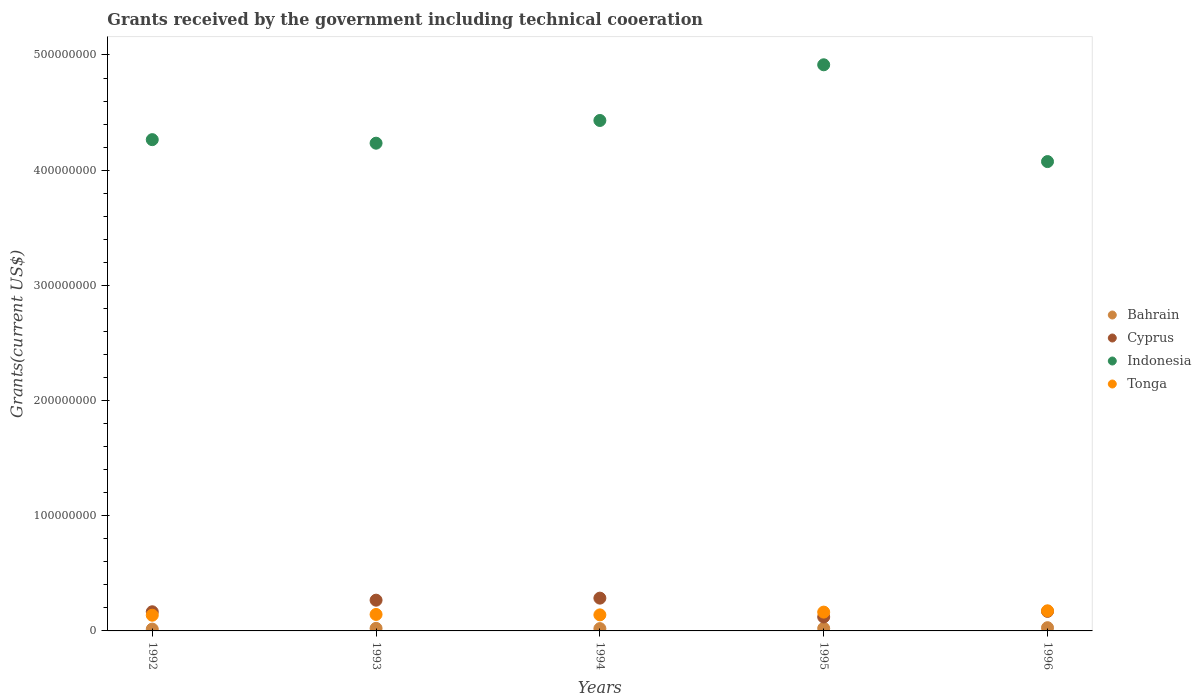How many different coloured dotlines are there?
Offer a terse response. 4. Is the number of dotlines equal to the number of legend labels?
Offer a very short reply. Yes. What is the total grants received by the government in Tonga in 1996?
Offer a terse response. 1.75e+07. Across all years, what is the maximum total grants received by the government in Bahrain?
Provide a succinct answer. 2.80e+06. Across all years, what is the minimum total grants received by the government in Bahrain?
Give a very brief answer. 1.59e+06. What is the total total grants received by the government in Bahrain in the graph?
Your response must be concise. 1.09e+07. What is the difference between the total grants received by the government in Tonga in 1994 and that in 1996?
Offer a very short reply. -3.53e+06. What is the difference between the total grants received by the government in Tonga in 1995 and the total grants received by the government in Indonesia in 1996?
Make the answer very short. -3.91e+08. What is the average total grants received by the government in Indonesia per year?
Offer a terse response. 4.38e+08. In the year 1994, what is the difference between the total grants received by the government in Bahrain and total grants received by the government in Cyprus?
Your answer should be very brief. -2.64e+07. In how many years, is the total grants received by the government in Tonga greater than 140000000 US$?
Your answer should be very brief. 0. What is the ratio of the total grants received by the government in Bahrain in 1993 to that in 1994?
Provide a succinct answer. 1.11. Is the difference between the total grants received by the government in Bahrain in 1993 and 1995 greater than the difference between the total grants received by the government in Cyprus in 1993 and 1995?
Your answer should be compact. No. What is the difference between the highest and the second highest total grants received by the government in Tonga?
Provide a succinct answer. 1.13e+06. What is the difference between the highest and the lowest total grants received by the government in Cyprus?
Your response must be concise. 1.64e+07. Is it the case that in every year, the sum of the total grants received by the government in Cyprus and total grants received by the government in Tonga  is greater than the total grants received by the government in Bahrain?
Give a very brief answer. Yes. Is the total grants received by the government in Indonesia strictly greater than the total grants received by the government in Bahrain over the years?
Offer a terse response. Yes. How many years are there in the graph?
Provide a short and direct response. 5. What is the difference between two consecutive major ticks on the Y-axis?
Ensure brevity in your answer.  1.00e+08. Does the graph contain grids?
Give a very brief answer. No. What is the title of the graph?
Ensure brevity in your answer.  Grants received by the government including technical cooeration. Does "Netherlands" appear as one of the legend labels in the graph?
Offer a terse response. No. What is the label or title of the X-axis?
Offer a terse response. Years. What is the label or title of the Y-axis?
Offer a very short reply. Grants(current US$). What is the Grants(current US$) of Bahrain in 1992?
Make the answer very short. 1.59e+06. What is the Grants(current US$) in Cyprus in 1992?
Your response must be concise. 1.66e+07. What is the Grants(current US$) of Indonesia in 1992?
Give a very brief answer. 4.26e+08. What is the Grants(current US$) in Tonga in 1992?
Ensure brevity in your answer.  1.36e+07. What is the Grants(current US$) in Bahrain in 1993?
Make the answer very short. 2.24e+06. What is the Grants(current US$) in Cyprus in 1993?
Your response must be concise. 2.67e+07. What is the Grants(current US$) of Indonesia in 1993?
Provide a succinct answer. 4.23e+08. What is the Grants(current US$) of Tonga in 1993?
Your response must be concise. 1.43e+07. What is the Grants(current US$) in Bahrain in 1994?
Keep it short and to the point. 2.02e+06. What is the Grants(current US$) of Cyprus in 1994?
Provide a succinct answer. 2.85e+07. What is the Grants(current US$) of Indonesia in 1994?
Provide a short and direct response. 4.43e+08. What is the Grants(current US$) of Tonga in 1994?
Your response must be concise. 1.39e+07. What is the Grants(current US$) of Bahrain in 1995?
Your answer should be compact. 2.24e+06. What is the Grants(current US$) of Cyprus in 1995?
Give a very brief answer. 1.21e+07. What is the Grants(current US$) in Indonesia in 1995?
Provide a succinct answer. 4.91e+08. What is the Grants(current US$) in Tonga in 1995?
Provide a succinct answer. 1.63e+07. What is the Grants(current US$) in Bahrain in 1996?
Offer a terse response. 2.80e+06. What is the Grants(current US$) of Cyprus in 1996?
Give a very brief answer. 1.70e+07. What is the Grants(current US$) in Indonesia in 1996?
Your answer should be compact. 4.07e+08. What is the Grants(current US$) in Tonga in 1996?
Keep it short and to the point. 1.75e+07. Across all years, what is the maximum Grants(current US$) in Bahrain?
Ensure brevity in your answer.  2.80e+06. Across all years, what is the maximum Grants(current US$) of Cyprus?
Your response must be concise. 2.85e+07. Across all years, what is the maximum Grants(current US$) in Indonesia?
Ensure brevity in your answer.  4.91e+08. Across all years, what is the maximum Grants(current US$) of Tonga?
Keep it short and to the point. 1.75e+07. Across all years, what is the minimum Grants(current US$) of Bahrain?
Make the answer very short. 1.59e+06. Across all years, what is the minimum Grants(current US$) in Cyprus?
Your answer should be very brief. 1.21e+07. Across all years, what is the minimum Grants(current US$) of Indonesia?
Your answer should be compact. 4.07e+08. Across all years, what is the minimum Grants(current US$) of Tonga?
Your answer should be very brief. 1.36e+07. What is the total Grants(current US$) of Bahrain in the graph?
Give a very brief answer. 1.09e+07. What is the total Grants(current US$) in Cyprus in the graph?
Make the answer very short. 1.01e+08. What is the total Grants(current US$) of Indonesia in the graph?
Provide a short and direct response. 2.19e+09. What is the total Grants(current US$) of Tonga in the graph?
Provide a succinct answer. 7.56e+07. What is the difference between the Grants(current US$) of Bahrain in 1992 and that in 1993?
Offer a very short reply. -6.50e+05. What is the difference between the Grants(current US$) of Cyprus in 1992 and that in 1993?
Provide a short and direct response. -1.01e+07. What is the difference between the Grants(current US$) in Indonesia in 1992 and that in 1993?
Keep it short and to the point. 3.07e+06. What is the difference between the Grants(current US$) of Tonga in 1992 and that in 1993?
Provide a succinct answer. -6.70e+05. What is the difference between the Grants(current US$) in Bahrain in 1992 and that in 1994?
Offer a very short reply. -4.30e+05. What is the difference between the Grants(current US$) of Cyprus in 1992 and that in 1994?
Make the answer very short. -1.18e+07. What is the difference between the Grants(current US$) in Indonesia in 1992 and that in 1994?
Offer a very short reply. -1.66e+07. What is the difference between the Grants(current US$) in Bahrain in 1992 and that in 1995?
Your response must be concise. -6.50e+05. What is the difference between the Grants(current US$) in Cyprus in 1992 and that in 1995?
Provide a short and direct response. 4.51e+06. What is the difference between the Grants(current US$) of Indonesia in 1992 and that in 1995?
Your response must be concise. -6.50e+07. What is the difference between the Grants(current US$) of Tonga in 1992 and that in 1995?
Your answer should be very brief. -2.70e+06. What is the difference between the Grants(current US$) in Bahrain in 1992 and that in 1996?
Offer a terse response. -1.21e+06. What is the difference between the Grants(current US$) of Cyprus in 1992 and that in 1996?
Offer a very short reply. -3.50e+05. What is the difference between the Grants(current US$) in Indonesia in 1992 and that in 1996?
Make the answer very short. 1.90e+07. What is the difference between the Grants(current US$) of Tonga in 1992 and that in 1996?
Your answer should be compact. -3.83e+06. What is the difference between the Grants(current US$) of Bahrain in 1993 and that in 1994?
Offer a very short reply. 2.20e+05. What is the difference between the Grants(current US$) of Cyprus in 1993 and that in 1994?
Provide a short and direct response. -1.77e+06. What is the difference between the Grants(current US$) of Indonesia in 1993 and that in 1994?
Keep it short and to the point. -1.97e+07. What is the difference between the Grants(current US$) in Bahrain in 1993 and that in 1995?
Keep it short and to the point. 0. What is the difference between the Grants(current US$) of Cyprus in 1993 and that in 1995?
Give a very brief answer. 1.46e+07. What is the difference between the Grants(current US$) in Indonesia in 1993 and that in 1995?
Give a very brief answer. -6.81e+07. What is the difference between the Grants(current US$) of Tonga in 1993 and that in 1995?
Provide a short and direct response. -2.03e+06. What is the difference between the Grants(current US$) of Bahrain in 1993 and that in 1996?
Your response must be concise. -5.60e+05. What is the difference between the Grants(current US$) in Cyprus in 1993 and that in 1996?
Give a very brief answer. 9.72e+06. What is the difference between the Grants(current US$) of Indonesia in 1993 and that in 1996?
Provide a succinct answer. 1.60e+07. What is the difference between the Grants(current US$) in Tonga in 1993 and that in 1996?
Make the answer very short. -3.16e+06. What is the difference between the Grants(current US$) of Cyprus in 1994 and that in 1995?
Make the answer very short. 1.64e+07. What is the difference between the Grants(current US$) in Indonesia in 1994 and that in 1995?
Give a very brief answer. -4.83e+07. What is the difference between the Grants(current US$) in Tonga in 1994 and that in 1995?
Make the answer very short. -2.40e+06. What is the difference between the Grants(current US$) in Bahrain in 1994 and that in 1996?
Make the answer very short. -7.80e+05. What is the difference between the Grants(current US$) in Cyprus in 1994 and that in 1996?
Keep it short and to the point. 1.15e+07. What is the difference between the Grants(current US$) in Indonesia in 1994 and that in 1996?
Keep it short and to the point. 3.57e+07. What is the difference between the Grants(current US$) in Tonga in 1994 and that in 1996?
Offer a very short reply. -3.53e+06. What is the difference between the Grants(current US$) of Bahrain in 1995 and that in 1996?
Your answer should be very brief. -5.60e+05. What is the difference between the Grants(current US$) of Cyprus in 1995 and that in 1996?
Provide a succinct answer. -4.86e+06. What is the difference between the Grants(current US$) in Indonesia in 1995 and that in 1996?
Your answer should be very brief. 8.40e+07. What is the difference between the Grants(current US$) of Tonga in 1995 and that in 1996?
Give a very brief answer. -1.13e+06. What is the difference between the Grants(current US$) in Bahrain in 1992 and the Grants(current US$) in Cyprus in 1993?
Make the answer very short. -2.51e+07. What is the difference between the Grants(current US$) in Bahrain in 1992 and the Grants(current US$) in Indonesia in 1993?
Provide a short and direct response. -4.22e+08. What is the difference between the Grants(current US$) of Bahrain in 1992 and the Grants(current US$) of Tonga in 1993?
Provide a short and direct response. -1.27e+07. What is the difference between the Grants(current US$) in Cyprus in 1992 and the Grants(current US$) in Indonesia in 1993?
Give a very brief answer. -4.07e+08. What is the difference between the Grants(current US$) of Cyprus in 1992 and the Grants(current US$) of Tonga in 1993?
Offer a very short reply. 2.32e+06. What is the difference between the Grants(current US$) of Indonesia in 1992 and the Grants(current US$) of Tonga in 1993?
Your answer should be very brief. 4.12e+08. What is the difference between the Grants(current US$) in Bahrain in 1992 and the Grants(current US$) in Cyprus in 1994?
Your response must be concise. -2.69e+07. What is the difference between the Grants(current US$) of Bahrain in 1992 and the Grants(current US$) of Indonesia in 1994?
Provide a short and direct response. -4.42e+08. What is the difference between the Grants(current US$) in Bahrain in 1992 and the Grants(current US$) in Tonga in 1994?
Ensure brevity in your answer.  -1.23e+07. What is the difference between the Grants(current US$) of Cyprus in 1992 and the Grants(current US$) of Indonesia in 1994?
Your answer should be very brief. -4.27e+08. What is the difference between the Grants(current US$) in Cyprus in 1992 and the Grants(current US$) in Tonga in 1994?
Your response must be concise. 2.69e+06. What is the difference between the Grants(current US$) in Indonesia in 1992 and the Grants(current US$) in Tonga in 1994?
Give a very brief answer. 4.13e+08. What is the difference between the Grants(current US$) in Bahrain in 1992 and the Grants(current US$) in Cyprus in 1995?
Offer a very short reply. -1.05e+07. What is the difference between the Grants(current US$) in Bahrain in 1992 and the Grants(current US$) in Indonesia in 1995?
Your answer should be very brief. -4.90e+08. What is the difference between the Grants(current US$) in Bahrain in 1992 and the Grants(current US$) in Tonga in 1995?
Give a very brief answer. -1.47e+07. What is the difference between the Grants(current US$) of Cyprus in 1992 and the Grants(current US$) of Indonesia in 1995?
Keep it short and to the point. -4.75e+08. What is the difference between the Grants(current US$) of Cyprus in 1992 and the Grants(current US$) of Tonga in 1995?
Keep it short and to the point. 2.90e+05. What is the difference between the Grants(current US$) of Indonesia in 1992 and the Grants(current US$) of Tonga in 1995?
Make the answer very short. 4.10e+08. What is the difference between the Grants(current US$) in Bahrain in 1992 and the Grants(current US$) in Cyprus in 1996?
Your response must be concise. -1.54e+07. What is the difference between the Grants(current US$) in Bahrain in 1992 and the Grants(current US$) in Indonesia in 1996?
Your answer should be compact. -4.06e+08. What is the difference between the Grants(current US$) in Bahrain in 1992 and the Grants(current US$) in Tonga in 1996?
Offer a terse response. -1.59e+07. What is the difference between the Grants(current US$) of Cyprus in 1992 and the Grants(current US$) of Indonesia in 1996?
Provide a succinct answer. -3.91e+08. What is the difference between the Grants(current US$) of Cyprus in 1992 and the Grants(current US$) of Tonga in 1996?
Your answer should be very brief. -8.40e+05. What is the difference between the Grants(current US$) of Indonesia in 1992 and the Grants(current US$) of Tonga in 1996?
Make the answer very short. 4.09e+08. What is the difference between the Grants(current US$) of Bahrain in 1993 and the Grants(current US$) of Cyprus in 1994?
Offer a terse response. -2.62e+07. What is the difference between the Grants(current US$) in Bahrain in 1993 and the Grants(current US$) in Indonesia in 1994?
Your answer should be very brief. -4.41e+08. What is the difference between the Grants(current US$) in Bahrain in 1993 and the Grants(current US$) in Tonga in 1994?
Make the answer very short. -1.17e+07. What is the difference between the Grants(current US$) of Cyprus in 1993 and the Grants(current US$) of Indonesia in 1994?
Your answer should be very brief. -4.16e+08. What is the difference between the Grants(current US$) in Cyprus in 1993 and the Grants(current US$) in Tonga in 1994?
Offer a very short reply. 1.28e+07. What is the difference between the Grants(current US$) of Indonesia in 1993 and the Grants(current US$) of Tonga in 1994?
Offer a very short reply. 4.09e+08. What is the difference between the Grants(current US$) of Bahrain in 1993 and the Grants(current US$) of Cyprus in 1995?
Your response must be concise. -9.87e+06. What is the difference between the Grants(current US$) of Bahrain in 1993 and the Grants(current US$) of Indonesia in 1995?
Provide a short and direct response. -4.89e+08. What is the difference between the Grants(current US$) in Bahrain in 1993 and the Grants(current US$) in Tonga in 1995?
Keep it short and to the point. -1.41e+07. What is the difference between the Grants(current US$) of Cyprus in 1993 and the Grants(current US$) of Indonesia in 1995?
Ensure brevity in your answer.  -4.65e+08. What is the difference between the Grants(current US$) in Cyprus in 1993 and the Grants(current US$) in Tonga in 1995?
Offer a very short reply. 1.04e+07. What is the difference between the Grants(current US$) in Indonesia in 1993 and the Grants(current US$) in Tonga in 1995?
Your answer should be compact. 4.07e+08. What is the difference between the Grants(current US$) in Bahrain in 1993 and the Grants(current US$) in Cyprus in 1996?
Your answer should be very brief. -1.47e+07. What is the difference between the Grants(current US$) in Bahrain in 1993 and the Grants(current US$) in Indonesia in 1996?
Your answer should be compact. -4.05e+08. What is the difference between the Grants(current US$) of Bahrain in 1993 and the Grants(current US$) of Tonga in 1996?
Your answer should be very brief. -1.52e+07. What is the difference between the Grants(current US$) in Cyprus in 1993 and the Grants(current US$) in Indonesia in 1996?
Your answer should be compact. -3.81e+08. What is the difference between the Grants(current US$) of Cyprus in 1993 and the Grants(current US$) of Tonga in 1996?
Provide a short and direct response. 9.23e+06. What is the difference between the Grants(current US$) of Indonesia in 1993 and the Grants(current US$) of Tonga in 1996?
Offer a very short reply. 4.06e+08. What is the difference between the Grants(current US$) in Bahrain in 1994 and the Grants(current US$) in Cyprus in 1995?
Your answer should be compact. -1.01e+07. What is the difference between the Grants(current US$) in Bahrain in 1994 and the Grants(current US$) in Indonesia in 1995?
Provide a succinct answer. -4.89e+08. What is the difference between the Grants(current US$) of Bahrain in 1994 and the Grants(current US$) of Tonga in 1995?
Your answer should be very brief. -1.43e+07. What is the difference between the Grants(current US$) in Cyprus in 1994 and the Grants(current US$) in Indonesia in 1995?
Give a very brief answer. -4.63e+08. What is the difference between the Grants(current US$) in Cyprus in 1994 and the Grants(current US$) in Tonga in 1995?
Keep it short and to the point. 1.21e+07. What is the difference between the Grants(current US$) in Indonesia in 1994 and the Grants(current US$) in Tonga in 1995?
Your answer should be very brief. 4.27e+08. What is the difference between the Grants(current US$) of Bahrain in 1994 and the Grants(current US$) of Cyprus in 1996?
Offer a terse response. -1.50e+07. What is the difference between the Grants(current US$) of Bahrain in 1994 and the Grants(current US$) of Indonesia in 1996?
Keep it short and to the point. -4.05e+08. What is the difference between the Grants(current US$) in Bahrain in 1994 and the Grants(current US$) in Tonga in 1996?
Offer a very short reply. -1.54e+07. What is the difference between the Grants(current US$) of Cyprus in 1994 and the Grants(current US$) of Indonesia in 1996?
Offer a very short reply. -3.79e+08. What is the difference between the Grants(current US$) of Cyprus in 1994 and the Grants(current US$) of Tonga in 1996?
Provide a succinct answer. 1.10e+07. What is the difference between the Grants(current US$) in Indonesia in 1994 and the Grants(current US$) in Tonga in 1996?
Offer a very short reply. 4.26e+08. What is the difference between the Grants(current US$) in Bahrain in 1995 and the Grants(current US$) in Cyprus in 1996?
Offer a very short reply. -1.47e+07. What is the difference between the Grants(current US$) in Bahrain in 1995 and the Grants(current US$) in Indonesia in 1996?
Your answer should be very brief. -4.05e+08. What is the difference between the Grants(current US$) of Bahrain in 1995 and the Grants(current US$) of Tonga in 1996?
Offer a terse response. -1.52e+07. What is the difference between the Grants(current US$) in Cyprus in 1995 and the Grants(current US$) in Indonesia in 1996?
Your answer should be very brief. -3.95e+08. What is the difference between the Grants(current US$) in Cyprus in 1995 and the Grants(current US$) in Tonga in 1996?
Offer a very short reply. -5.35e+06. What is the difference between the Grants(current US$) in Indonesia in 1995 and the Grants(current US$) in Tonga in 1996?
Offer a terse response. 4.74e+08. What is the average Grants(current US$) in Bahrain per year?
Ensure brevity in your answer.  2.18e+06. What is the average Grants(current US$) in Cyprus per year?
Offer a terse response. 2.02e+07. What is the average Grants(current US$) of Indonesia per year?
Ensure brevity in your answer.  4.38e+08. What is the average Grants(current US$) in Tonga per year?
Your answer should be compact. 1.51e+07. In the year 1992, what is the difference between the Grants(current US$) of Bahrain and Grants(current US$) of Cyprus?
Your answer should be very brief. -1.50e+07. In the year 1992, what is the difference between the Grants(current US$) of Bahrain and Grants(current US$) of Indonesia?
Make the answer very short. -4.25e+08. In the year 1992, what is the difference between the Grants(current US$) in Bahrain and Grants(current US$) in Tonga?
Offer a very short reply. -1.20e+07. In the year 1992, what is the difference between the Grants(current US$) in Cyprus and Grants(current US$) in Indonesia?
Ensure brevity in your answer.  -4.10e+08. In the year 1992, what is the difference between the Grants(current US$) of Cyprus and Grants(current US$) of Tonga?
Ensure brevity in your answer.  2.99e+06. In the year 1992, what is the difference between the Grants(current US$) in Indonesia and Grants(current US$) in Tonga?
Your answer should be very brief. 4.13e+08. In the year 1993, what is the difference between the Grants(current US$) in Bahrain and Grants(current US$) in Cyprus?
Offer a terse response. -2.44e+07. In the year 1993, what is the difference between the Grants(current US$) in Bahrain and Grants(current US$) in Indonesia?
Give a very brief answer. -4.21e+08. In the year 1993, what is the difference between the Grants(current US$) of Bahrain and Grants(current US$) of Tonga?
Offer a very short reply. -1.21e+07. In the year 1993, what is the difference between the Grants(current US$) in Cyprus and Grants(current US$) in Indonesia?
Offer a terse response. -3.97e+08. In the year 1993, what is the difference between the Grants(current US$) in Cyprus and Grants(current US$) in Tonga?
Provide a short and direct response. 1.24e+07. In the year 1993, what is the difference between the Grants(current US$) of Indonesia and Grants(current US$) of Tonga?
Ensure brevity in your answer.  4.09e+08. In the year 1994, what is the difference between the Grants(current US$) of Bahrain and Grants(current US$) of Cyprus?
Ensure brevity in your answer.  -2.64e+07. In the year 1994, what is the difference between the Grants(current US$) of Bahrain and Grants(current US$) of Indonesia?
Your answer should be very brief. -4.41e+08. In the year 1994, what is the difference between the Grants(current US$) of Bahrain and Grants(current US$) of Tonga?
Offer a terse response. -1.19e+07. In the year 1994, what is the difference between the Grants(current US$) in Cyprus and Grants(current US$) in Indonesia?
Make the answer very short. -4.15e+08. In the year 1994, what is the difference between the Grants(current US$) of Cyprus and Grants(current US$) of Tonga?
Provide a succinct answer. 1.45e+07. In the year 1994, what is the difference between the Grants(current US$) in Indonesia and Grants(current US$) in Tonga?
Keep it short and to the point. 4.29e+08. In the year 1995, what is the difference between the Grants(current US$) in Bahrain and Grants(current US$) in Cyprus?
Give a very brief answer. -9.87e+06. In the year 1995, what is the difference between the Grants(current US$) in Bahrain and Grants(current US$) in Indonesia?
Offer a very short reply. -4.89e+08. In the year 1995, what is the difference between the Grants(current US$) of Bahrain and Grants(current US$) of Tonga?
Keep it short and to the point. -1.41e+07. In the year 1995, what is the difference between the Grants(current US$) of Cyprus and Grants(current US$) of Indonesia?
Your response must be concise. -4.79e+08. In the year 1995, what is the difference between the Grants(current US$) in Cyprus and Grants(current US$) in Tonga?
Give a very brief answer. -4.22e+06. In the year 1995, what is the difference between the Grants(current US$) of Indonesia and Grants(current US$) of Tonga?
Give a very brief answer. 4.75e+08. In the year 1996, what is the difference between the Grants(current US$) of Bahrain and Grants(current US$) of Cyprus?
Your answer should be very brief. -1.42e+07. In the year 1996, what is the difference between the Grants(current US$) of Bahrain and Grants(current US$) of Indonesia?
Provide a succinct answer. -4.05e+08. In the year 1996, what is the difference between the Grants(current US$) of Bahrain and Grants(current US$) of Tonga?
Offer a very short reply. -1.47e+07. In the year 1996, what is the difference between the Grants(current US$) of Cyprus and Grants(current US$) of Indonesia?
Ensure brevity in your answer.  -3.90e+08. In the year 1996, what is the difference between the Grants(current US$) in Cyprus and Grants(current US$) in Tonga?
Make the answer very short. -4.90e+05. In the year 1996, what is the difference between the Grants(current US$) of Indonesia and Grants(current US$) of Tonga?
Provide a succinct answer. 3.90e+08. What is the ratio of the Grants(current US$) of Bahrain in 1992 to that in 1993?
Give a very brief answer. 0.71. What is the ratio of the Grants(current US$) in Cyprus in 1992 to that in 1993?
Your answer should be compact. 0.62. What is the ratio of the Grants(current US$) in Indonesia in 1992 to that in 1993?
Offer a very short reply. 1.01. What is the ratio of the Grants(current US$) of Tonga in 1992 to that in 1993?
Give a very brief answer. 0.95. What is the ratio of the Grants(current US$) of Bahrain in 1992 to that in 1994?
Your response must be concise. 0.79. What is the ratio of the Grants(current US$) in Cyprus in 1992 to that in 1994?
Provide a succinct answer. 0.58. What is the ratio of the Grants(current US$) in Indonesia in 1992 to that in 1994?
Offer a terse response. 0.96. What is the ratio of the Grants(current US$) of Tonga in 1992 to that in 1994?
Give a very brief answer. 0.98. What is the ratio of the Grants(current US$) of Bahrain in 1992 to that in 1995?
Keep it short and to the point. 0.71. What is the ratio of the Grants(current US$) of Cyprus in 1992 to that in 1995?
Your response must be concise. 1.37. What is the ratio of the Grants(current US$) in Indonesia in 1992 to that in 1995?
Offer a terse response. 0.87. What is the ratio of the Grants(current US$) in Tonga in 1992 to that in 1995?
Make the answer very short. 0.83. What is the ratio of the Grants(current US$) of Bahrain in 1992 to that in 1996?
Make the answer very short. 0.57. What is the ratio of the Grants(current US$) of Cyprus in 1992 to that in 1996?
Keep it short and to the point. 0.98. What is the ratio of the Grants(current US$) in Indonesia in 1992 to that in 1996?
Your response must be concise. 1.05. What is the ratio of the Grants(current US$) in Tonga in 1992 to that in 1996?
Provide a short and direct response. 0.78. What is the ratio of the Grants(current US$) of Bahrain in 1993 to that in 1994?
Ensure brevity in your answer.  1.11. What is the ratio of the Grants(current US$) in Cyprus in 1993 to that in 1994?
Make the answer very short. 0.94. What is the ratio of the Grants(current US$) in Indonesia in 1993 to that in 1994?
Ensure brevity in your answer.  0.96. What is the ratio of the Grants(current US$) of Tonga in 1993 to that in 1994?
Make the answer very short. 1.03. What is the ratio of the Grants(current US$) in Cyprus in 1993 to that in 1995?
Offer a very short reply. 2.2. What is the ratio of the Grants(current US$) of Indonesia in 1993 to that in 1995?
Make the answer very short. 0.86. What is the ratio of the Grants(current US$) of Tonga in 1993 to that in 1995?
Keep it short and to the point. 0.88. What is the ratio of the Grants(current US$) in Bahrain in 1993 to that in 1996?
Offer a terse response. 0.8. What is the ratio of the Grants(current US$) of Cyprus in 1993 to that in 1996?
Your response must be concise. 1.57. What is the ratio of the Grants(current US$) of Indonesia in 1993 to that in 1996?
Your answer should be very brief. 1.04. What is the ratio of the Grants(current US$) of Tonga in 1993 to that in 1996?
Offer a very short reply. 0.82. What is the ratio of the Grants(current US$) of Bahrain in 1994 to that in 1995?
Make the answer very short. 0.9. What is the ratio of the Grants(current US$) of Cyprus in 1994 to that in 1995?
Your response must be concise. 2.35. What is the ratio of the Grants(current US$) in Indonesia in 1994 to that in 1995?
Make the answer very short. 0.9. What is the ratio of the Grants(current US$) in Tonga in 1994 to that in 1995?
Provide a succinct answer. 0.85. What is the ratio of the Grants(current US$) of Bahrain in 1994 to that in 1996?
Give a very brief answer. 0.72. What is the ratio of the Grants(current US$) in Cyprus in 1994 to that in 1996?
Give a very brief answer. 1.68. What is the ratio of the Grants(current US$) of Indonesia in 1994 to that in 1996?
Provide a short and direct response. 1.09. What is the ratio of the Grants(current US$) of Tonga in 1994 to that in 1996?
Ensure brevity in your answer.  0.8. What is the ratio of the Grants(current US$) of Cyprus in 1995 to that in 1996?
Make the answer very short. 0.71. What is the ratio of the Grants(current US$) of Indonesia in 1995 to that in 1996?
Your answer should be compact. 1.21. What is the ratio of the Grants(current US$) of Tonga in 1995 to that in 1996?
Give a very brief answer. 0.94. What is the difference between the highest and the second highest Grants(current US$) in Bahrain?
Your answer should be compact. 5.60e+05. What is the difference between the highest and the second highest Grants(current US$) of Cyprus?
Offer a terse response. 1.77e+06. What is the difference between the highest and the second highest Grants(current US$) of Indonesia?
Offer a very short reply. 4.83e+07. What is the difference between the highest and the second highest Grants(current US$) in Tonga?
Make the answer very short. 1.13e+06. What is the difference between the highest and the lowest Grants(current US$) in Bahrain?
Give a very brief answer. 1.21e+06. What is the difference between the highest and the lowest Grants(current US$) of Cyprus?
Give a very brief answer. 1.64e+07. What is the difference between the highest and the lowest Grants(current US$) of Indonesia?
Provide a succinct answer. 8.40e+07. What is the difference between the highest and the lowest Grants(current US$) of Tonga?
Keep it short and to the point. 3.83e+06. 